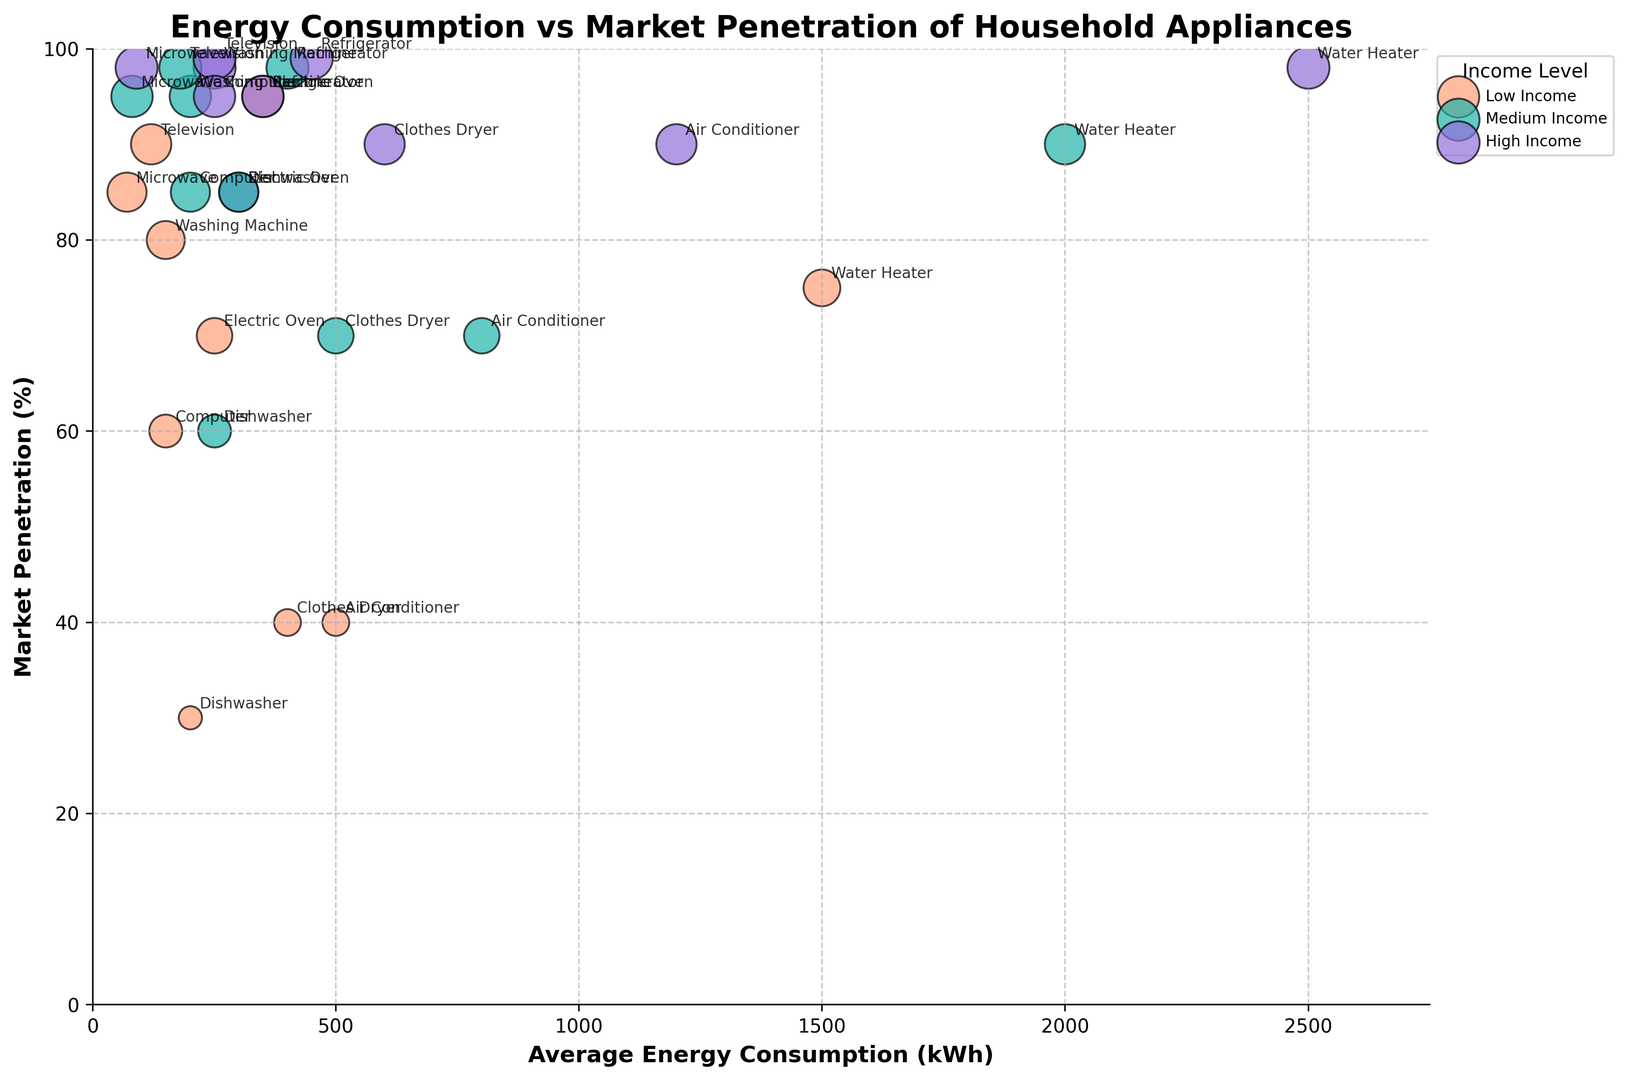What are the average energy consumption and market penetration for the high-income group for Air Conditioners? Find the high-income data point for Air Conditioners: average energy consumption is 1200 kWh and market penetration is 90%.
Answer: 1200 kWh, 90% How does the market penetration of Dishwashers differ between low and high-income groups? Compare the market penetration values for Dishwashers: Low (30%) and High (85%). The difference is 85% - 30% = 55%.
Answer: 55% Which appliance has the highest average energy consumption in the medium-income group? Look for the highest average energy consumption value in the medium-income group, which is 2000 kWh for Water Heaters.
Answer: Water Heater What is the combined market penetration for Refrigerators and Televisions in the low-income group? Add the market penetration values for Refrigerators (95%) and Televisions (90%) in the low-income group: 95% + 90% = 185%.
Answer: 185% Which appliance shows the largest range of average energy consumption across all income levels? Evaluate the range (difference between highest and lowest values) for each appliance: Air Conditioner ranges from 500 kWh to 1200 kWh, i.e., 700 kWh. This is the largest range.
Answer: Air Conditioner Is the market penetration of Washing Machines in the medium-income group higher or lower than that of Electric Ovens in the high-income group? Compare the market penetration values: Washing Machines (95%) and Electric Ovens (95%) in respective groups. They are equal.
Answer: Equal Which appliance in the high-income group has the smallest bubble size and what does that represent? The smallest bubble in the high-income group represents the appliance with the lowest market penetration value. The Dishwasher (85%) shows the smallest bubble size.
Answer: Dishwasher Does the average energy consumption of Computers change significantly between income levels? Review the average energy consumption values for Computers: Low (150 kWh), Medium (200 kWh), High (250 kWh). The changes are incremental and relatively small.
Answer: No What is the difference in market penetration between Computers and Microwaves in the medium-income group? Subtract the market penetration values: Computers (85%) - Microwaves (95%) = -10%.
Answer: -10% How does the energy consumption of Refrigerators compare with Air Conditioners in the low-income group? Compare the values for Refrigerators (350 kWh) and Air Conditioners (500 kWh) in the low-income group. Air Conditioner’s consumption is higher.
Answer: Air Conditioner higher 